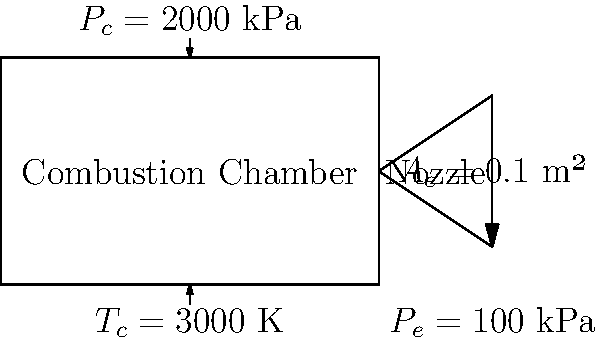Using the diagram of a rocket engine's combustion chamber and nozzle, calculate the specific impulse ($I_{sp}$) in seconds. Given:
- Chamber pressure ($P_c$) = 2000 kPa
- Chamber temperature ($T_c$) = 3000 K
- Nozzle exit area ($A_e$) = 0.1 m²
- Nozzle exit pressure ($P_e$) = 100 kPa
- Propellant mass flow rate ($\dot{m}$) = 5 kg/s
- Gravitational acceleration ($g_0$) = 9.81 m/s²
- Gas constant ($R$) = 287 J/(kg·K)
- Specific heat ratio ($\gamma$) = 1.4 To calculate the specific impulse, we'll follow these steps:

1) First, calculate the exit velocity ($v_e$) using the rocket equation:

   $$v_e = \sqrt{\frac{2\gamma}{\gamma-1} R T_c \left[1 - \left(\frac{P_e}{P_c}\right)^{\frac{\gamma-1}{\gamma}}\right]}$$

2) Substitute the given values:

   $$v_e = \sqrt{\frac{2(1.4)}{1.4-1} (287)(3000) \left[1 - \left(\frac{100}{2000}\right)^{\frac{1.4-1}{1.4}}\right]}$$

3) Calculate:

   $$v_e = \sqrt{(7)(287)(3000)(0.6634)} = 2,236.7 \text{ m/s}$$

4) Calculate the thrust ($F$) using the thrust equation:

   $$F = \dot{m}v_e + (P_e - P_a)A_e$$

   Where $P_a$ is atmospheric pressure, assumed to be 100 kPa (sea level).

5) Substitute values:

   $$F = (5)(2,236.7) + (100,000 - 100,000)(0.1) = 11,183.5 \text{ N}$$

6) Calculate specific impulse:

   $$I_{sp} = \frac{F}{\dot{m}g_0}$$

7) Substitute values:

   $$I_{sp} = \frac{11,183.5}{(5)(9.81)} = 228.1 \text{ seconds}$$

Therefore, the specific impulse of the rocket engine is approximately 228.1 seconds.
Answer: 228.1 seconds 